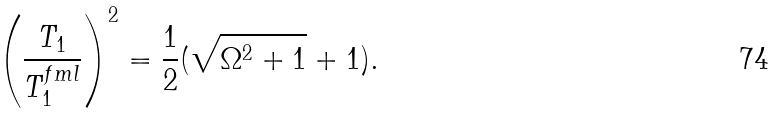<formula> <loc_0><loc_0><loc_500><loc_500>\left ( \frac { T _ { 1 } } { T _ { 1 } ^ { f m l } } \right ) ^ { 2 } = \frac { 1 } { 2 } ( \sqrt { \Omega ^ { 2 } + 1 } + 1 ) .</formula> 